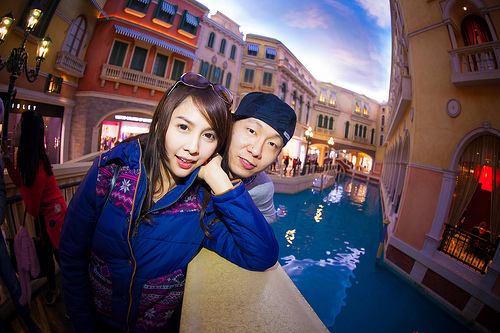<image>
Is there a girl to the left of the boy? Yes. From this viewpoint, the girl is positioned to the left side relative to the boy. 